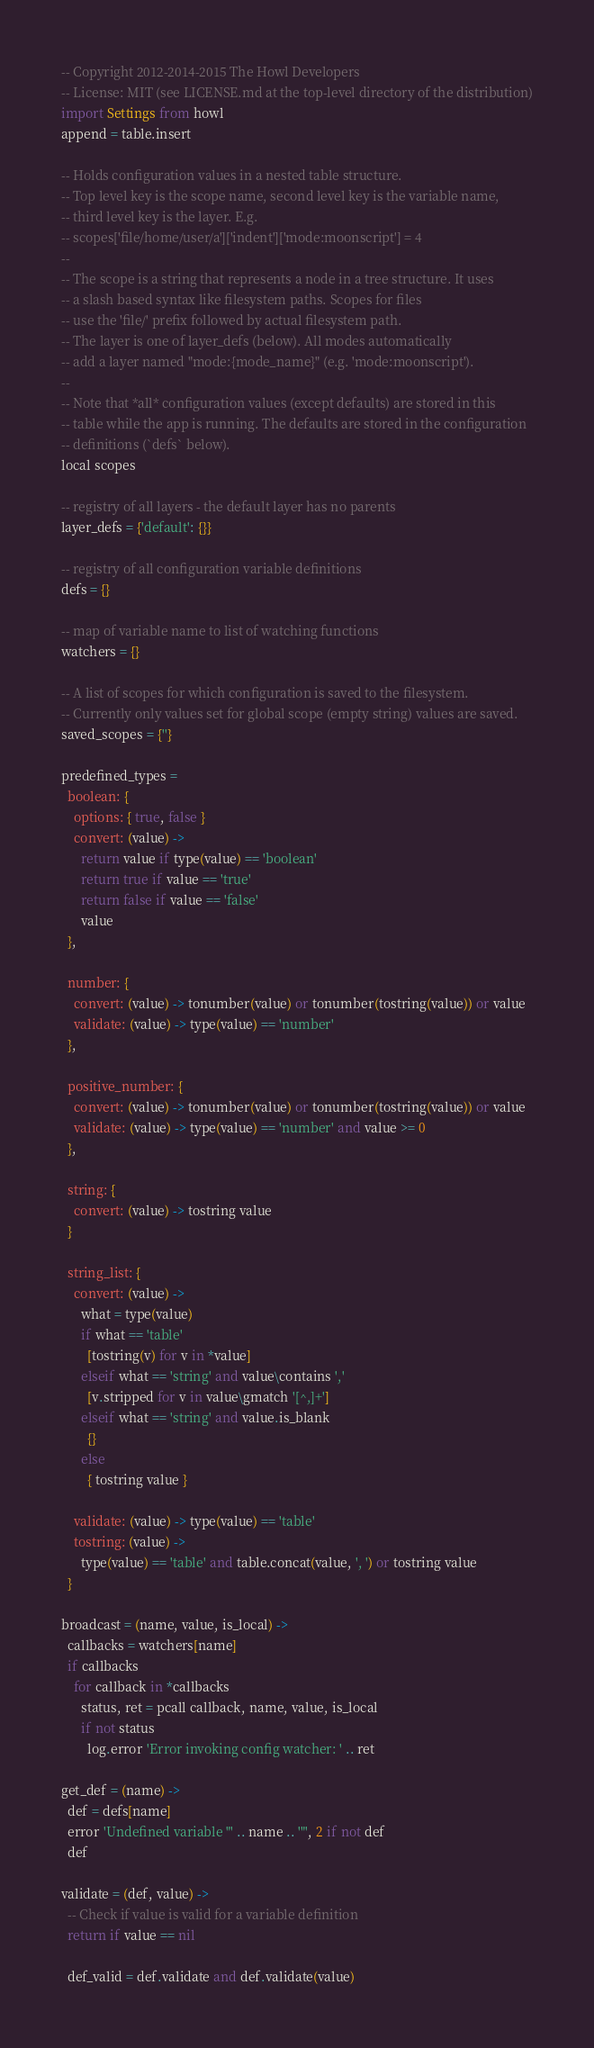<code> <loc_0><loc_0><loc_500><loc_500><_MoonScript_>-- Copyright 2012-2014-2015 The Howl Developers
-- License: MIT (see LICENSE.md at the top-level directory of the distribution)
import Settings from howl
append = table.insert

-- Holds configuration values in a nested table structure.
-- Top level key is the scope name, second level key is the variable name,
-- third level key is the layer. E.g.
-- scopes['file/home/user/a']['indent']['mode:moonscript'] = 4
--
-- The scope is a string that represents a node in a tree structure. It uses
-- a slash based syntax like filesystem paths. Scopes for files
-- use the 'file/' prefix followed by actual filesystem path.
-- The layer is one of layer_defs (below). All modes automatically
-- add a layer named "mode:{mode_name}" (e.g. 'mode:moonscript').
--
-- Note that *all* configuration values (except defaults) are stored in this
-- table while the app is running. The defaults are stored in the configuration
-- definitions (`defs` below).
local scopes

-- registry of all layers - the default layer has no parents
layer_defs = {'default': {}}

-- registry of all configuration variable definitions
defs = {}

-- map of variable name to list of watching functions
watchers = {}

-- A list of scopes for which configuration is saved to the filesystem.
-- Currently only values set for global scope (empty string) values are saved.
saved_scopes = {''}

predefined_types =
  boolean: {
    options: { true, false }
    convert: (value) ->
      return value if type(value) == 'boolean'
      return true if value == 'true'
      return false if value == 'false'
      value
  },

  number: {
    convert: (value) -> tonumber(value) or tonumber(tostring(value)) or value
    validate: (value) -> type(value) == 'number'
  },

  positive_number: {
    convert: (value) -> tonumber(value) or tonumber(tostring(value)) or value
    validate: (value) -> type(value) == 'number' and value >= 0
  },

  string: {
    convert: (value) -> tostring value
  }

  string_list: {
    convert: (value) ->
      what = type(value)
      if what == 'table'
        [tostring(v) for v in *value]
      elseif what == 'string' and value\contains ','
        [v.stripped for v in value\gmatch '[^,]+']
      elseif what == 'string' and value.is_blank
        {}
      else
        { tostring value }

    validate: (value) -> type(value) == 'table'
    tostring: (value) ->
      type(value) == 'table' and table.concat(value, ', ') or tostring value
  }

broadcast = (name, value, is_local) ->
  callbacks = watchers[name]
  if callbacks
    for callback in *callbacks
      status, ret = pcall callback, name, value, is_local
      if not status
        log.error 'Error invoking config watcher: ' .. ret

get_def = (name) ->
  def = defs[name]
  error 'Undefined variable "' .. name .. '"', 2 if not def
  def

validate = (def, value) ->
  -- Check if value is valid for a variable definition
  return if value == nil

  def_valid = def.validate and def.validate(value)</code> 